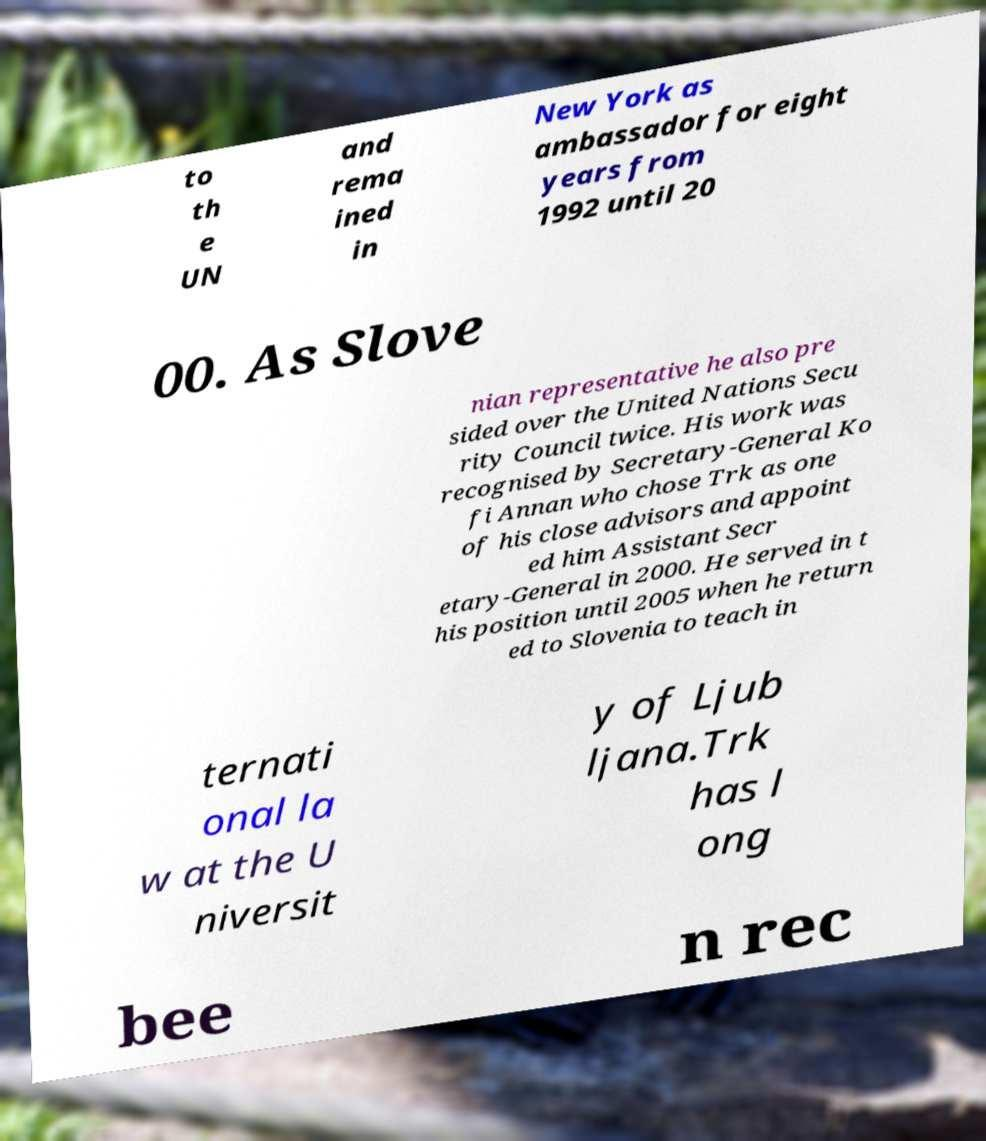Please read and relay the text visible in this image. What does it say? to th e UN and rema ined in New York as ambassador for eight years from 1992 until 20 00. As Slove nian representative he also pre sided over the United Nations Secu rity Council twice. His work was recognised by Secretary-General Ko fi Annan who chose Trk as one of his close advisors and appoint ed him Assistant Secr etary-General in 2000. He served in t his position until 2005 when he return ed to Slovenia to teach in ternati onal la w at the U niversit y of Ljub ljana.Trk has l ong bee n rec 